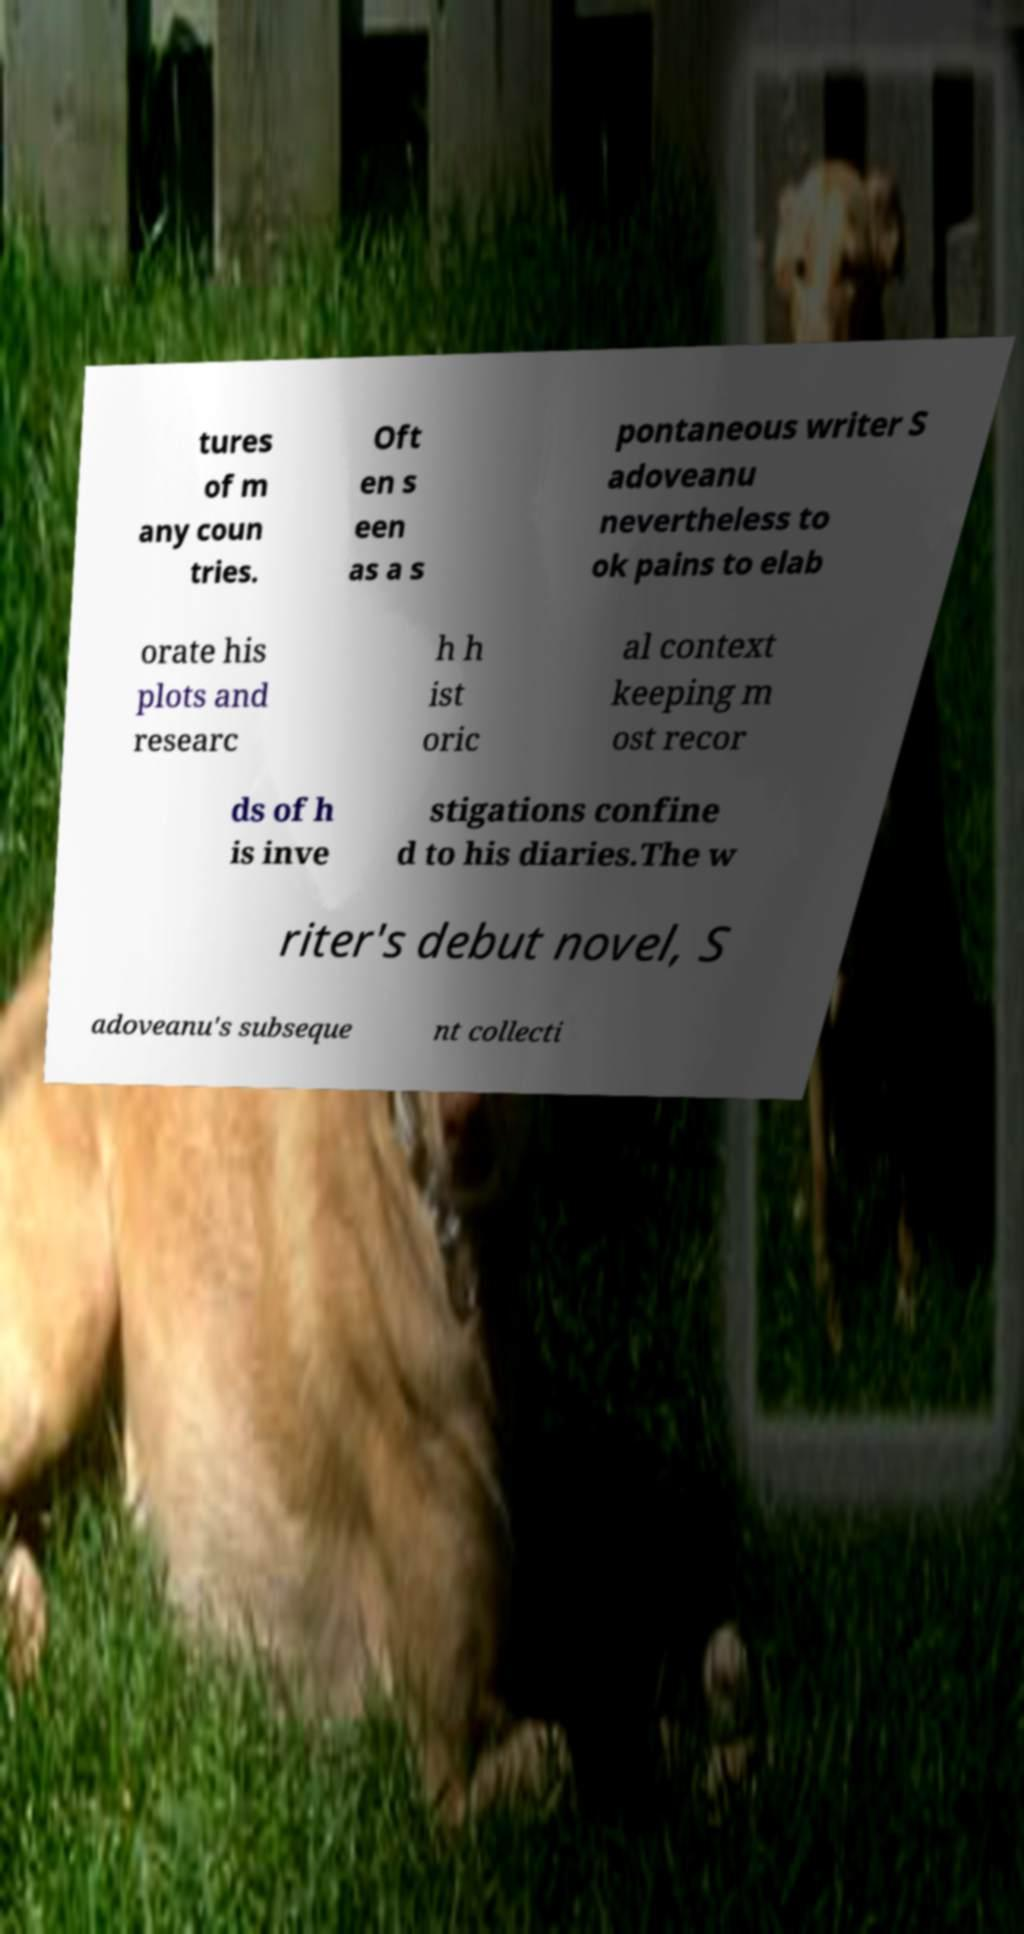What messages or text are displayed in this image? I need them in a readable, typed format. tures of m any coun tries. Oft en s een as a s pontaneous writer S adoveanu nevertheless to ok pains to elab orate his plots and researc h h ist oric al context keeping m ost recor ds of h is inve stigations confine d to his diaries.The w riter's debut novel, S adoveanu's subseque nt collecti 